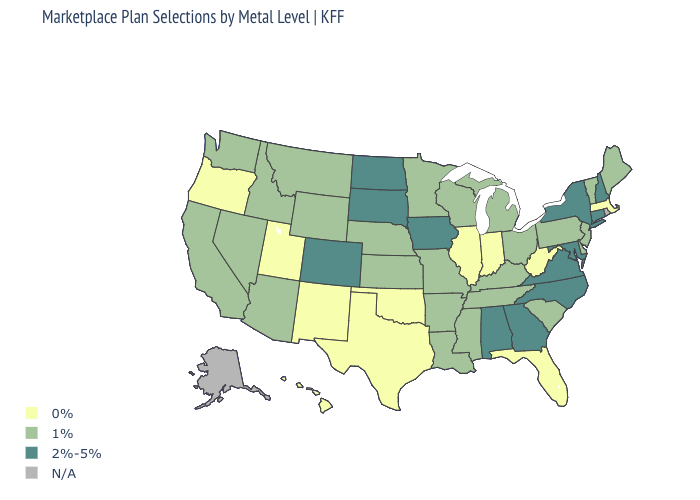Name the states that have a value in the range 2%-5%?
Write a very short answer. Alabama, Colorado, Connecticut, Georgia, Iowa, Maryland, New Hampshire, New York, North Carolina, North Dakota, South Dakota, Virginia. Is the legend a continuous bar?
Give a very brief answer. No. Among the states that border Oregon , which have the highest value?
Be succinct. California, Idaho, Nevada, Washington. Among the states that border Utah , does New Mexico have the lowest value?
Be succinct. Yes. What is the lowest value in the West?
Answer briefly. 0%. Among the states that border Nebraska , which have the lowest value?
Quick response, please. Kansas, Missouri, Wyoming. What is the value of Colorado?
Keep it brief. 2%-5%. What is the lowest value in states that border Nebraska?
Answer briefly. 1%. Among the states that border Kansas , does Colorado have the lowest value?
Be succinct. No. Does Pennsylvania have the highest value in the Northeast?
Be succinct. No. What is the value of Virginia?
Concise answer only. 2%-5%. What is the highest value in the USA?
Short answer required. 2%-5%. Name the states that have a value in the range 2%-5%?
Be succinct. Alabama, Colorado, Connecticut, Georgia, Iowa, Maryland, New Hampshire, New York, North Carolina, North Dakota, South Dakota, Virginia. 